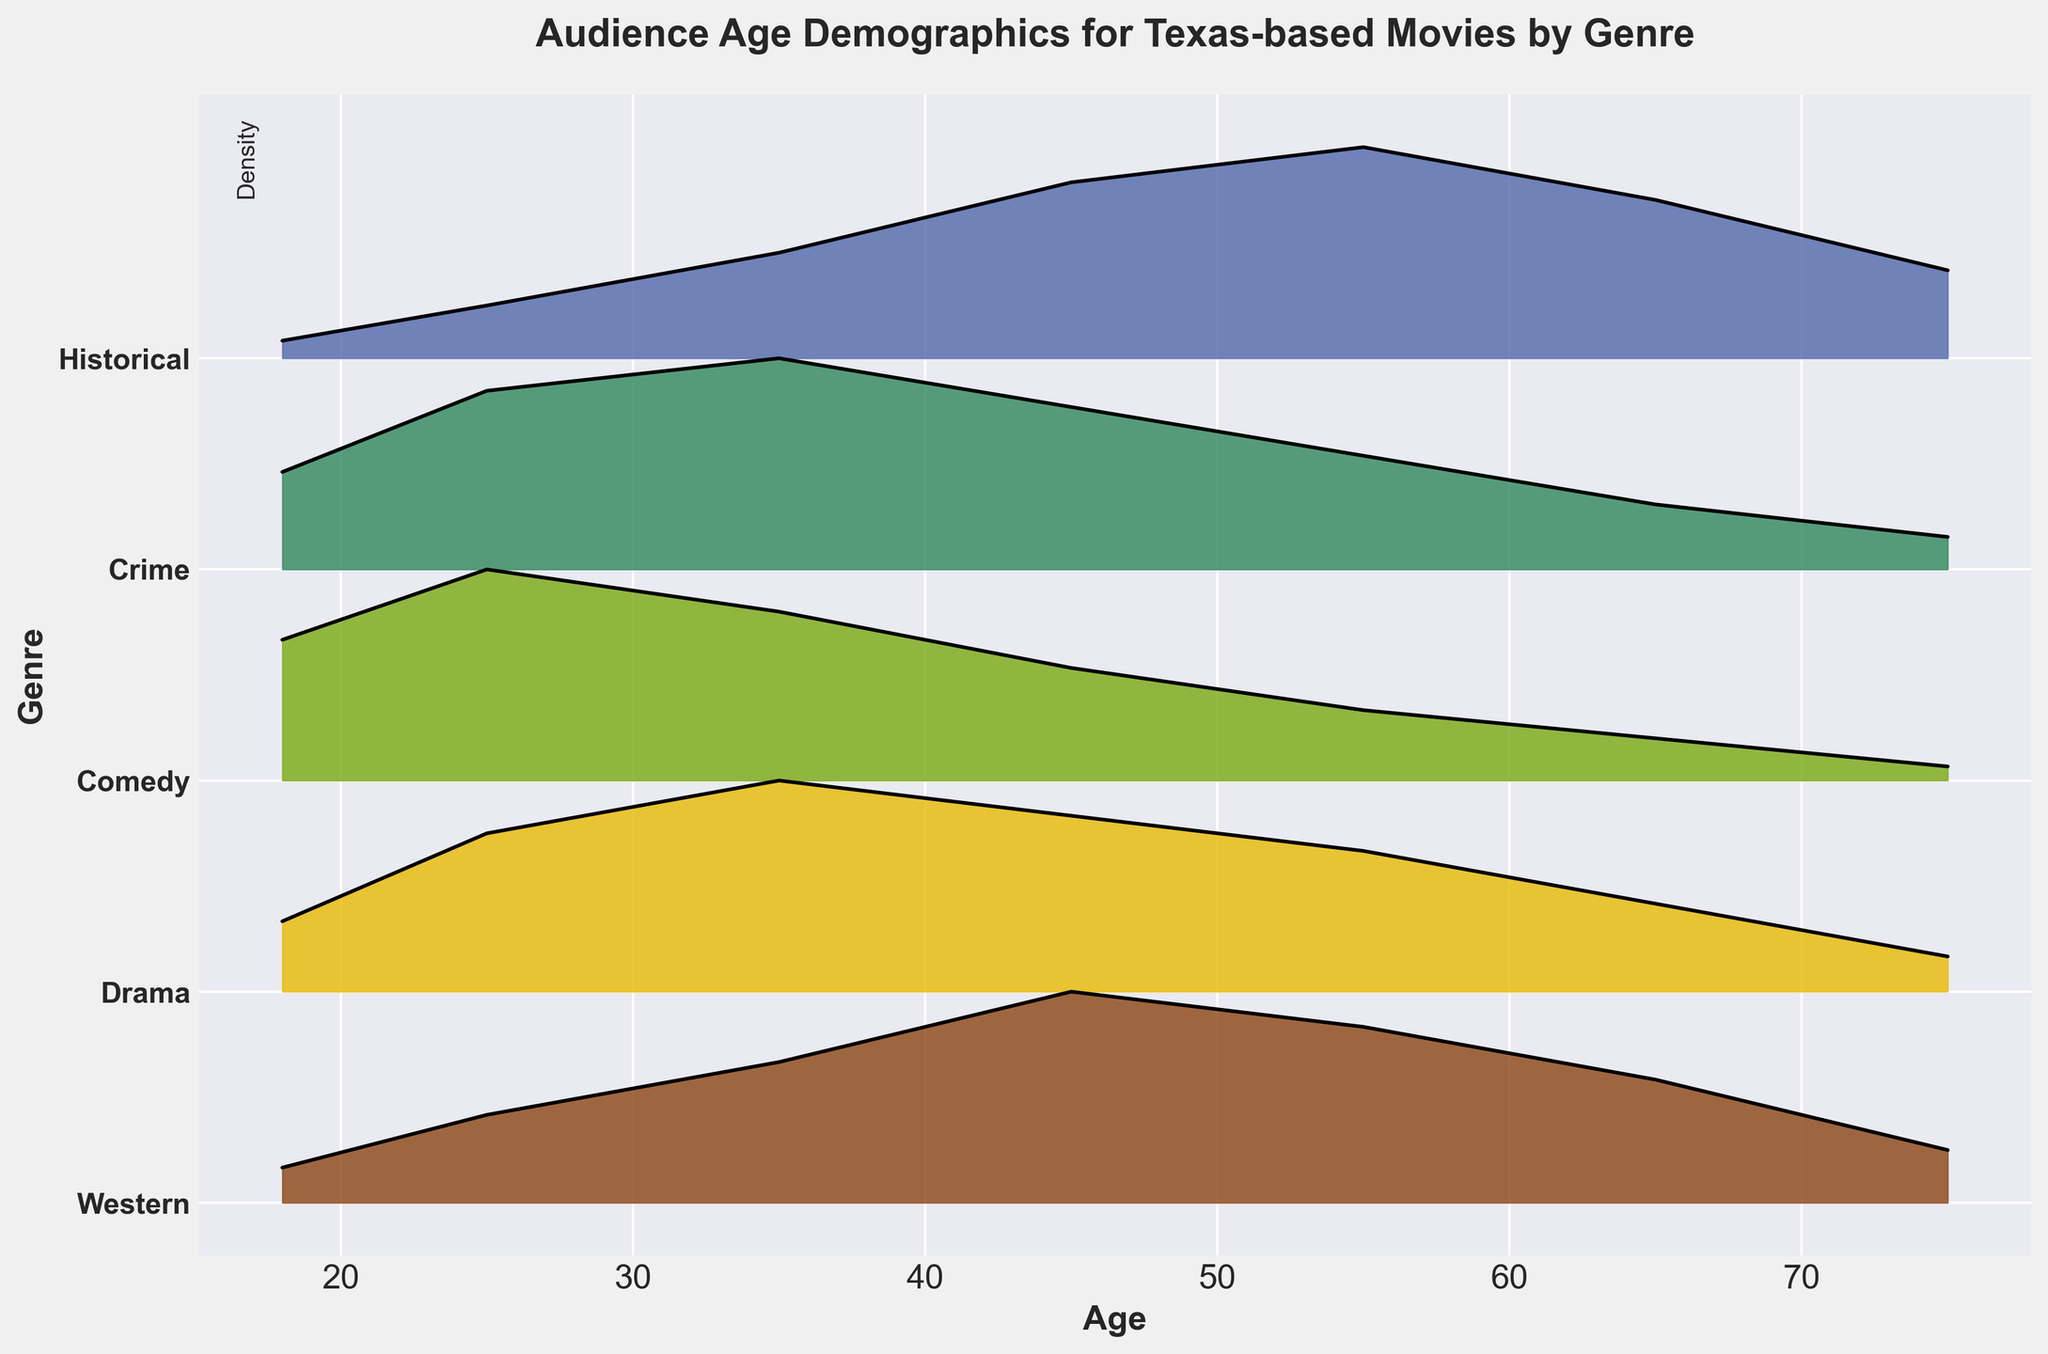What's the title of the plot? The title is prominently displayed at the top of the plot.
Answer: Audience Age Demographics for Texas-based Movies by Genre What are the genres listed on the y-axis? The y-axis labels show the names of the genres.
Answer: Western, Drama, Comedy, Crime, Historical Which genre has the highest density for the age group 25? By comparing the heights of the density lines for different genres at age 25, the highest peak can be observed.
Answer: Comedy At what age does the density of Western movies peak? By observing the highest point on the density line for Western movies, we note the age group at which this occurs.
Answer: 45 Which genre shows a peak density at age 55? By examining the plot and identifying the genre that has a peak at age 55, we determine the genre.
Answer: Historical What is the density value for Drama movies at age 35? Find the point on the density line for Drama movies at age 35 and read the corresponding density value.
Answer: 0.12 Compare the density trends between Comedy and Crime genres. Which one has a higher density for younger audiences (age 18-25)? Compare the density values for Comedy and Crime at ages 18 and 25. Comedy has higher density values for these ages.
Answer: Comedy How does the density for Historical movies change as age increases from 18 to 75? Follow the density line for Historical movies from age 18 to 75 and describe how it changes, noting the increases and peaks.
Answer: Increases initially, peaks at 55, then decreases Which genres have a peak density at age 45? Identify the genres that reach their highest density at age 45 by observing the density lines.
Answer: Western, Historical What is the general trend for the density of audiences aged 65 and above across different genres? Look at the density values at age 65 and 75 across all genres and summarize the overall trend.
Answer: Decreasing density 